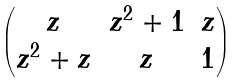Convert formula to latex. <formula><loc_0><loc_0><loc_500><loc_500>\begin{pmatrix} z & z ^ { 2 } + 1 & z \\ z ^ { 2 } + z & z & 1 \end{pmatrix}</formula> 